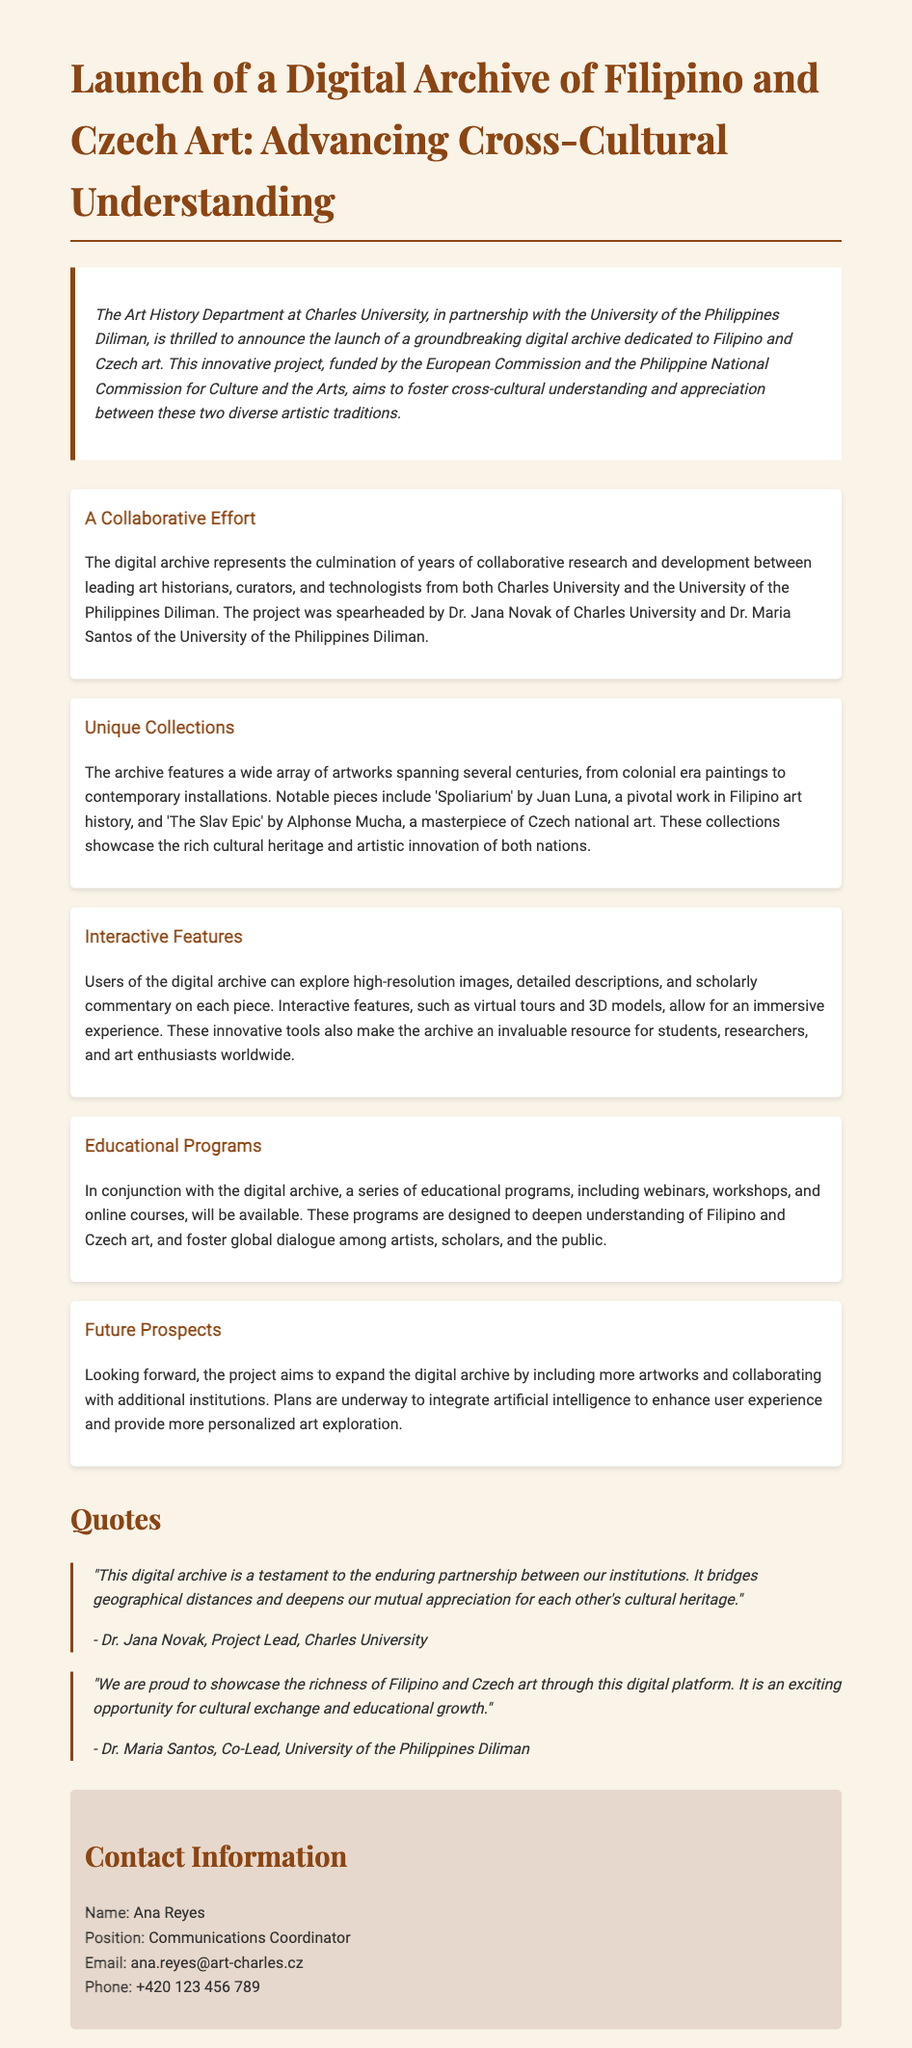What is the title of the digital archive? The title of the digital archive is mentioned in the heading of the document.
Answer: Launch of a Digital Archive of Filipino and Czech Art: Advancing Cross-Cultural Understanding Who are the project leads? The document states that Dr. Jana Novak and Dr. Maria Santos are the project leads.
Answer: Dr. Jana Novak and Dr. Maria Santos Which organization funded the project? The document states that the project is funded by the European Commission and the Philippine National Commission for Culture and the Arts.
Answer: European Commission and the Philippine National Commission for Culture and the Arts What type of programs will accompany the digital archive? The document describes educational programs such as webinars, workshops, and online courses as accompanying the digital archive.
Answer: Webinars, workshops, and online courses What notable Filipino artwork is featured in the archive? The document mentions 'Spoliarium' by Juan Luna as a notable piece in Filipino art history featured in the archive.
Answer: 'Spoliarium' by Juan Luna How does the digital archive enhance user experience? The document refers to the integration of artificial intelligence as a future enhancement to user experience.
Answer: Artificial intelligence What two universities collaborated on the project? The document states that Charles University and the University of the Philippines Diliman collaborated on the project.
Answer: Charles University and the University of the Philippines Diliman What is the contact email for the Communications Coordinator? The document provides the email address of the Communications Coordinator in the contact section.
Answer: ana.reyes@art-charles.cz 